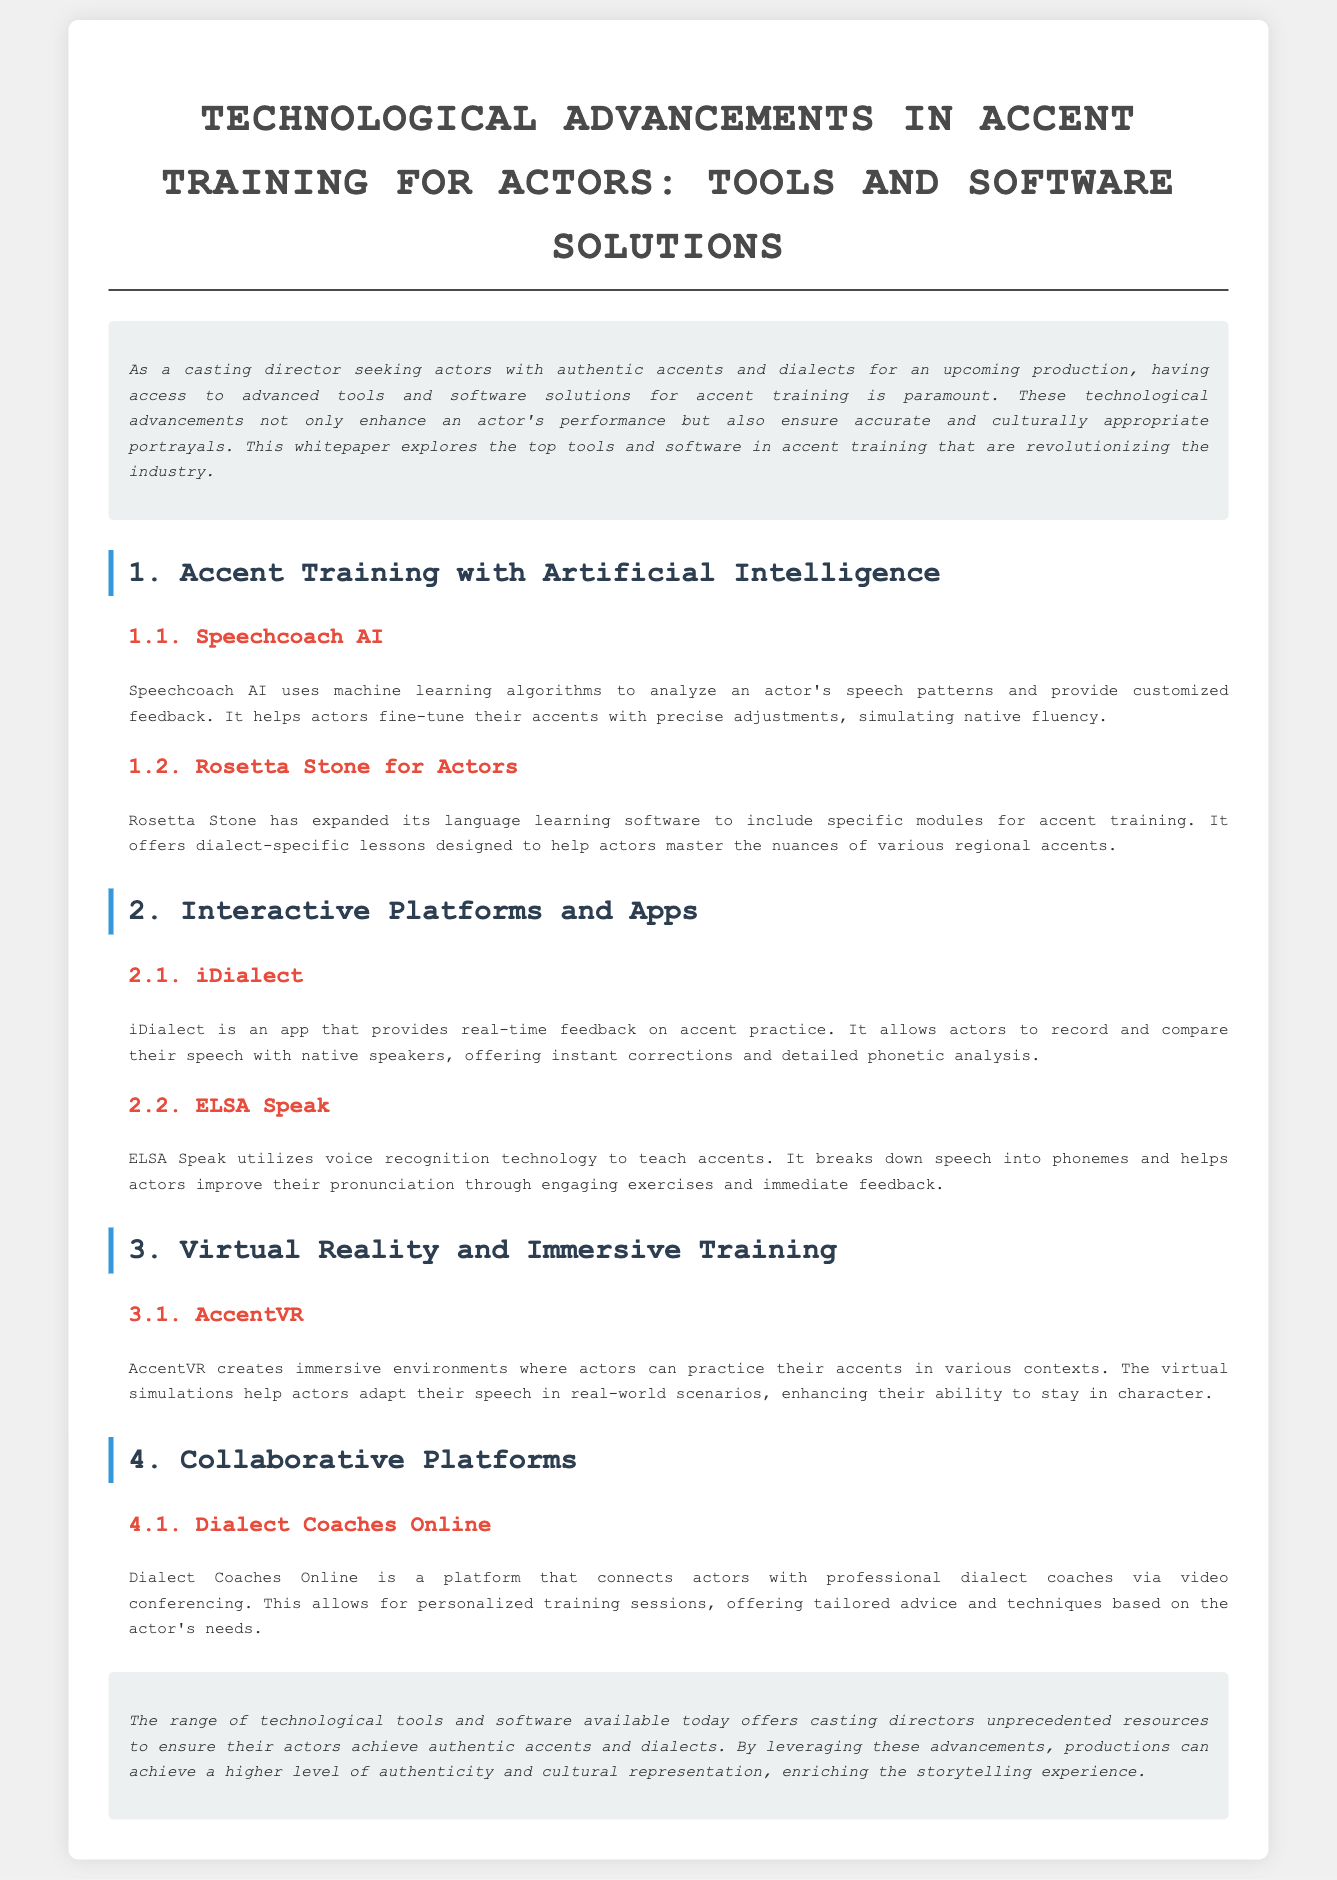What is the title of the whitepaper? The title is found in the header of the document, which clearly states the focus of the research.
Answer: Technological Advancements in Accent Training for Actors: Tools and Software Solutions What is one tool mentioned for accent training with artificial intelligence? The document lists specific tools under each section, and one notable entry is highlighted in the AI section.
Answer: Speechcoach AI What app provides real-time feedback on accent practice? The document specifies various apps in the interactive platforms section, including one that focuses on real-time feedback.
Answer: iDialect What technology does ELSA Speak utilize? The description of ELSA Speak in the document indicates it uses a specific technological element for teaching accents.
Answer: Voice recognition What immersive solution helps actors practice accents in various contexts? The document lists immersive training solutions, naming one specifically focused on creating environments for practice.
Answer: AccentVR What platform connects actors with dialect coaches? The document includes a section dedicated to collaborative platforms, indicating a specific service for direct coaching.
Answer: Dialect Coaches Online How many accent training tools are categorized under “Interactive Platforms and Apps”? By examining the count of subsection headers under the Interactive Platforms section, the number can be derived.
Answer: Two What is the purpose of Speechcoach AI? The document explains the function of Speechcoach AI in the context of accent training, focusing on the type of feedback it provides.
Answer: Customized feedback What does the conclusion emphasize regarding technological tools? The conclusion summarizes the overall impact of the tools discussed, specifically their effect on productions.
Answer: Higher level of authenticity 